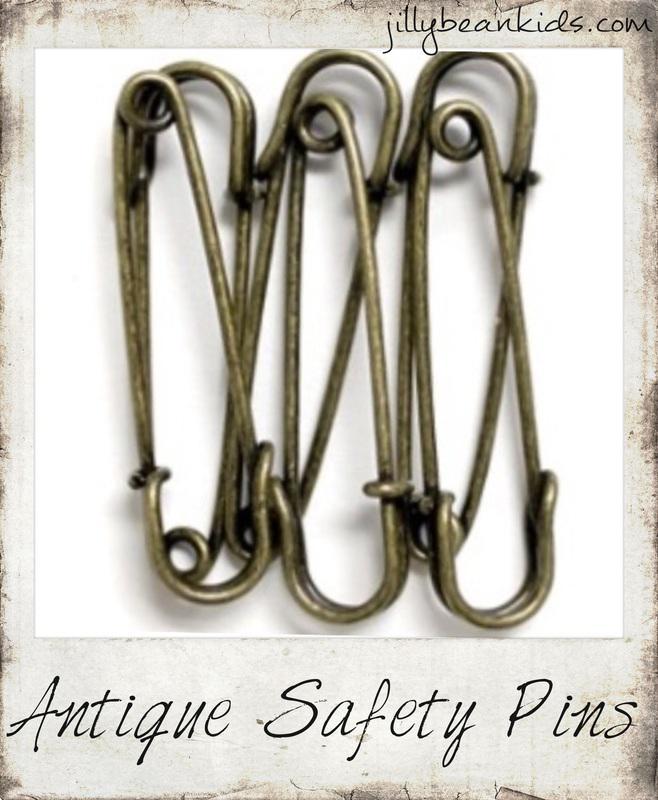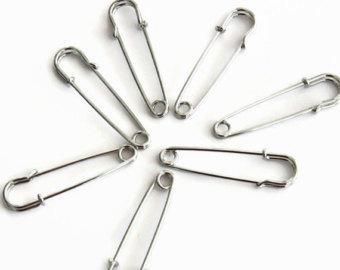The first image is the image on the left, the second image is the image on the right. Given the left and right images, does the statement "There are cloths pins grouped together with at least one of the pin tops colored white." hold true? Answer yes or no. No. The first image is the image on the left, the second image is the image on the right. Considering the images on both sides, is "At least one paperclip is a color other than silver or white." valid? Answer yes or no. No. 